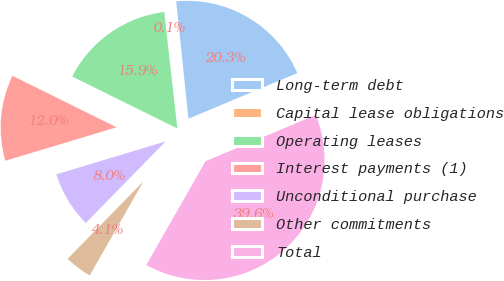<chart> <loc_0><loc_0><loc_500><loc_500><pie_chart><fcel>Long-term debt<fcel>Capital lease obligations<fcel>Operating leases<fcel>Interest payments (1)<fcel>Unconditional purchase<fcel>Other commitments<fcel>Total<nl><fcel>20.33%<fcel>0.13%<fcel>15.91%<fcel>11.96%<fcel>8.02%<fcel>4.07%<fcel>39.58%<nl></chart> 